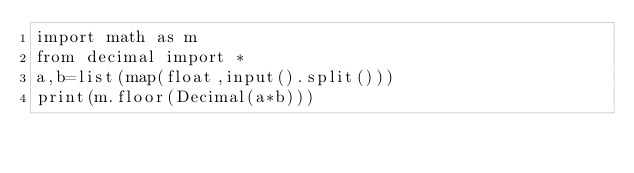Convert code to text. <code><loc_0><loc_0><loc_500><loc_500><_Python_>import math as m
from decimal import *
a,b=list(map(float,input().split()))
print(m.floor(Decimal(a*b)))</code> 